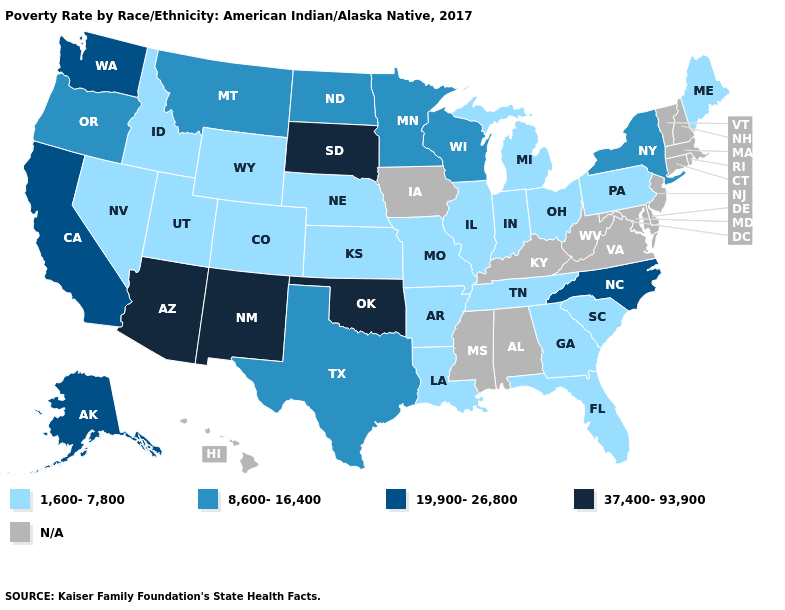What is the lowest value in the Northeast?
Give a very brief answer. 1,600-7,800. Which states have the lowest value in the MidWest?
Be succinct. Illinois, Indiana, Kansas, Michigan, Missouri, Nebraska, Ohio. Does the map have missing data?
Quick response, please. Yes. Name the states that have a value in the range 37,400-93,900?
Answer briefly. Arizona, New Mexico, Oklahoma, South Dakota. What is the lowest value in the USA?
Answer briefly. 1,600-7,800. Among the states that border Montana , which have the lowest value?
Short answer required. Idaho, Wyoming. What is the lowest value in the West?
Short answer required. 1,600-7,800. Among the states that border South Carolina , does North Carolina have the lowest value?
Write a very short answer. No. What is the lowest value in states that border Nevada?
Keep it brief. 1,600-7,800. What is the value of Indiana?
Answer briefly. 1,600-7,800. Among the states that border New York , which have the lowest value?
Answer briefly. Pennsylvania. Name the states that have a value in the range N/A?
Give a very brief answer. Alabama, Connecticut, Delaware, Hawaii, Iowa, Kentucky, Maryland, Massachusetts, Mississippi, New Hampshire, New Jersey, Rhode Island, Vermont, Virginia, West Virginia. What is the lowest value in the South?
Quick response, please. 1,600-7,800. Name the states that have a value in the range N/A?
Keep it brief. Alabama, Connecticut, Delaware, Hawaii, Iowa, Kentucky, Maryland, Massachusetts, Mississippi, New Hampshire, New Jersey, Rhode Island, Vermont, Virginia, West Virginia. 